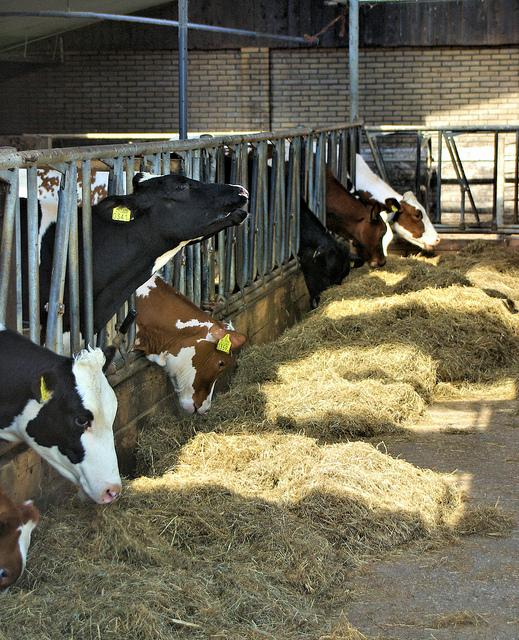Which way is the black cow with yellow tag facing?

Choices:
A) west
B) forward
C) south
D) down west 